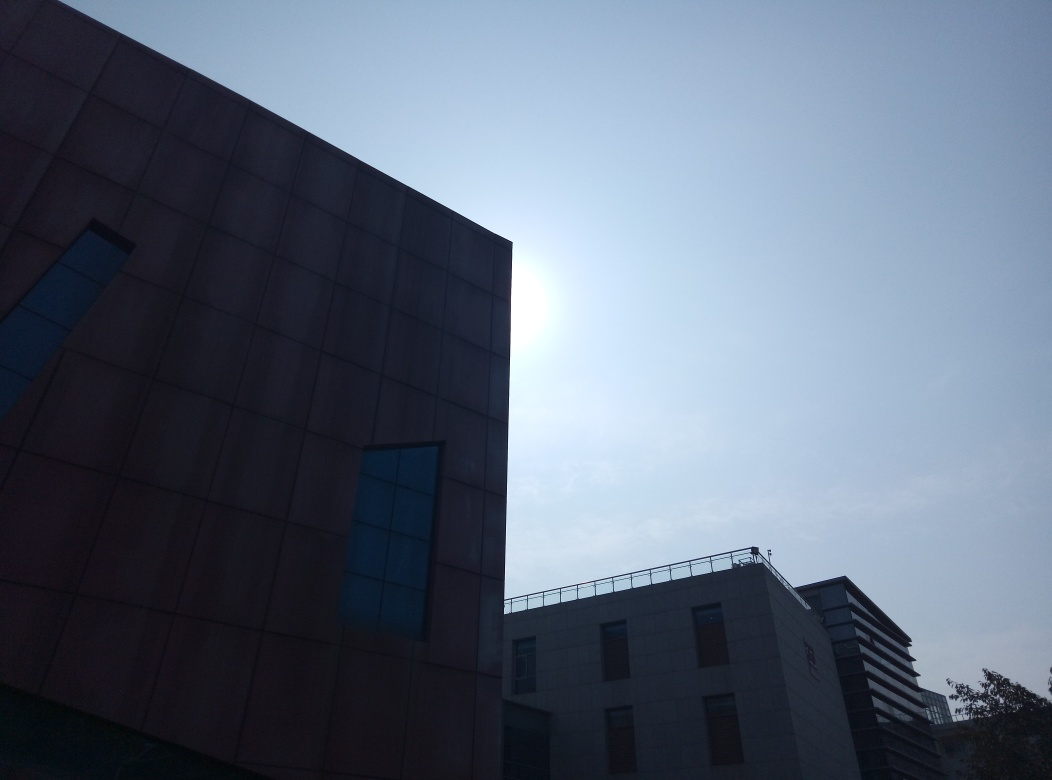Can you tell me what time of the day it might be in this image? Based on the position and intensity of the sunlight visible above the building, it appears to be either morning or late afternoon, as the sun seems to be at a lower angle in the sky. 